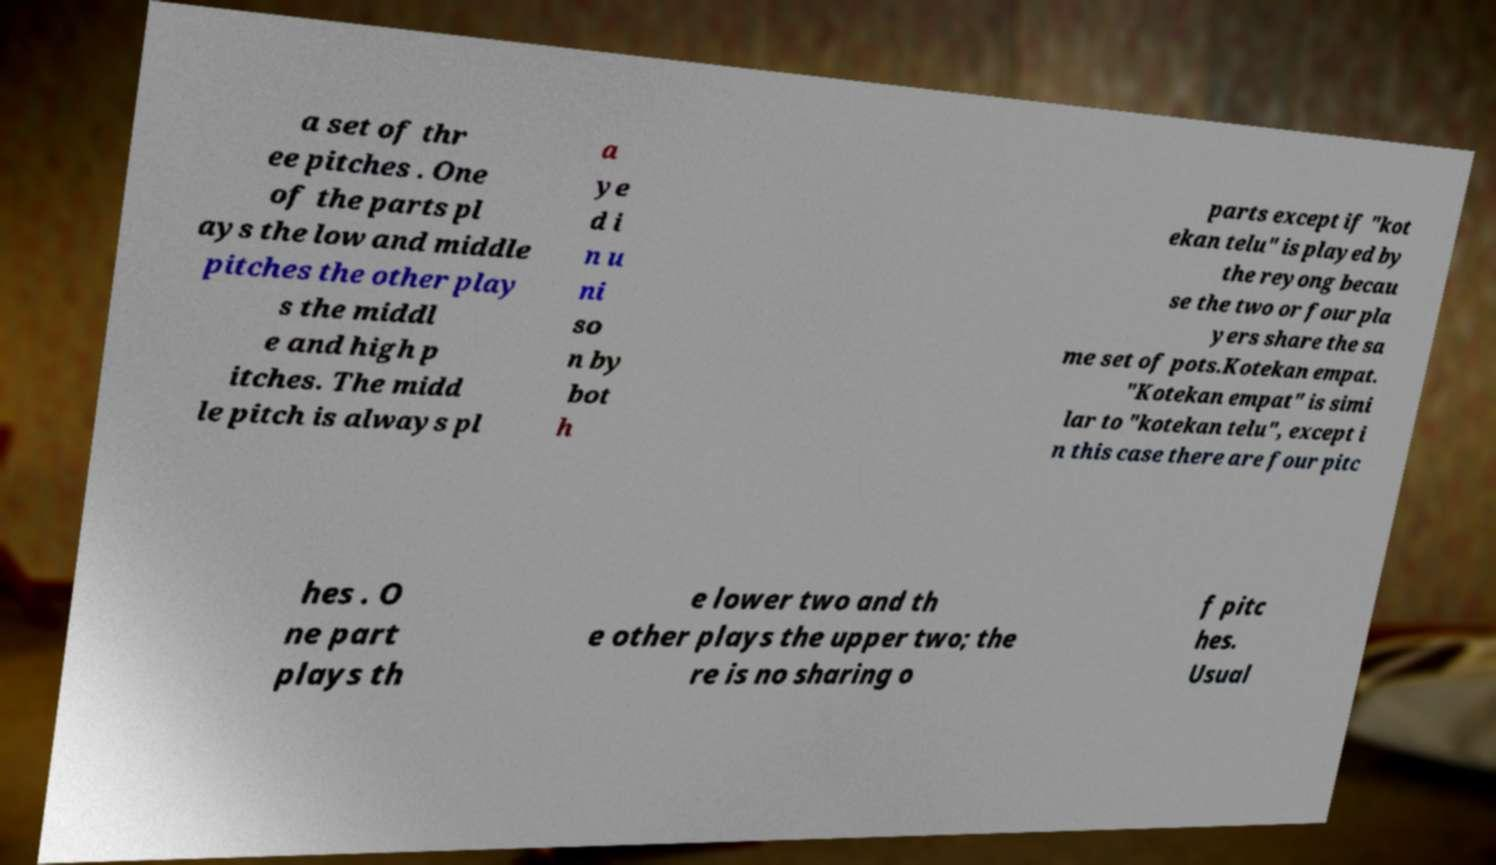Can you accurately transcribe the text from the provided image for me? a set of thr ee pitches . One of the parts pl ays the low and middle pitches the other play s the middl e and high p itches. The midd le pitch is always pl a ye d i n u ni so n by bot h parts except if "kot ekan telu" is played by the reyong becau se the two or four pla yers share the sa me set of pots.Kotekan empat. "Kotekan empat" is simi lar to "kotekan telu", except i n this case there are four pitc hes . O ne part plays th e lower two and th e other plays the upper two; the re is no sharing o f pitc hes. Usual 